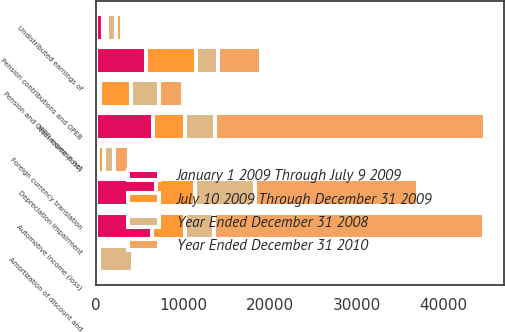Convert chart to OTSL. <chart><loc_0><loc_0><loc_500><loc_500><stacked_bar_chart><ecel><fcel>Net income (loss)<fcel>Automotive income (loss)<fcel>Depreciation impairment<fcel>Foreign currency translation<fcel>Amortization of discount and<fcel>Undistributed earnings of<fcel>Pension contributions and OPEB<fcel>Pension and OPEB expense net<nl><fcel>January 1 2009 Through July 9 2009<fcel>6503<fcel>6413<fcel>6923<fcel>209<fcel>163<fcel>753<fcel>5723<fcel>412<nl><fcel>July 10 2009 Through December 31 2009<fcel>3786<fcel>3786<fcel>4511<fcel>755<fcel>140<fcel>497<fcel>5832<fcel>3570<nl><fcel>Year Ended December 31 2008<fcel>3402<fcel>3402<fcel>6873<fcel>1077<fcel>3897<fcel>1036<fcel>2472<fcel>3234<nl><fcel>Year Ended December 31 2010<fcel>31051<fcel>31051<fcel>18724<fcel>1705<fcel>189<fcel>727<fcel>4898<fcel>2747<nl></chart> 